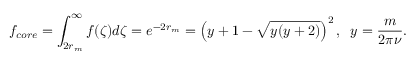Convert formula to latex. <formula><loc_0><loc_0><loc_500><loc_500>f _ { c o r e } = \int _ { 2 r _ { m } } ^ { \infty } f ( \zeta ) d \zeta = e ^ { - 2 r _ { m } } = \left ( y + 1 - \sqrt { y ( y + 2 ) } \right ) ^ { 2 } , \, y = \frac { m } { 2 \pi \nu } .</formula> 